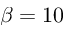<formula> <loc_0><loc_0><loc_500><loc_500>\beta = 1 0</formula> 